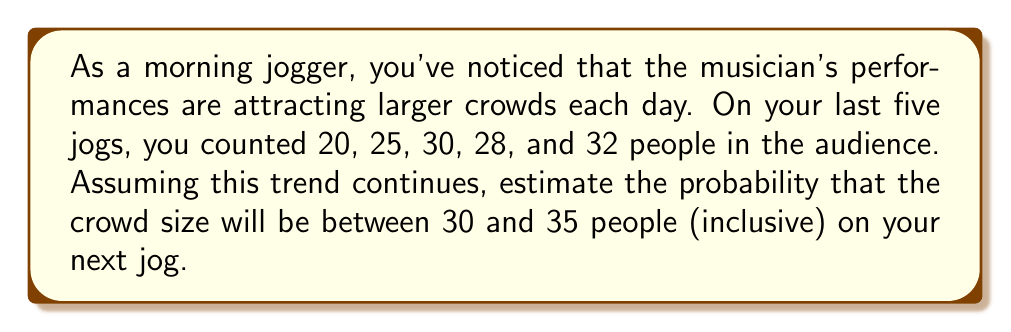What is the answer to this math problem? To solve this problem, we'll use basic statistics and probability concepts:

1. Calculate the mean ($\mu$) of the observed crowd sizes:
   $$\mu = \frac{20 + 25 + 30 + 28 + 32}{5} = 27$$

2. Calculate the standard deviation ($\sigma$) of the crowd sizes:
   $$\sigma = \sqrt{\frac{\sum(x - \mu)^2}{n}}$$
   $$\sigma = \sqrt{\frac{(-7)^2 + (-2)^2 + 3^2 + 1^2 + 5^2}{5}} \approx 4.69$$

3. Assuming a normal distribution, we can use the z-score formula to standardize our range:
   $$z = \frac{x - \mu}{\sigma}$$

   For the lower bound (30): $z_1 = \frac{30 - 27}{4.69} \approx 0.64$
   For the upper bound (35): $z_2 = \frac{35 - 27}{4.69} \approx 1.71$

4. Use a standard normal distribution table or calculator to find the area between these z-scores:
   $P(0.64 < z < 1.71) \approx 0.2389$

This represents the probability that the crowd size will be between 30 and 35 people on your next jog.
Answer: The probability that the crowd size will be between 30 and 35 people (inclusive) on your next jog is approximately 0.2389 or 23.89%. 